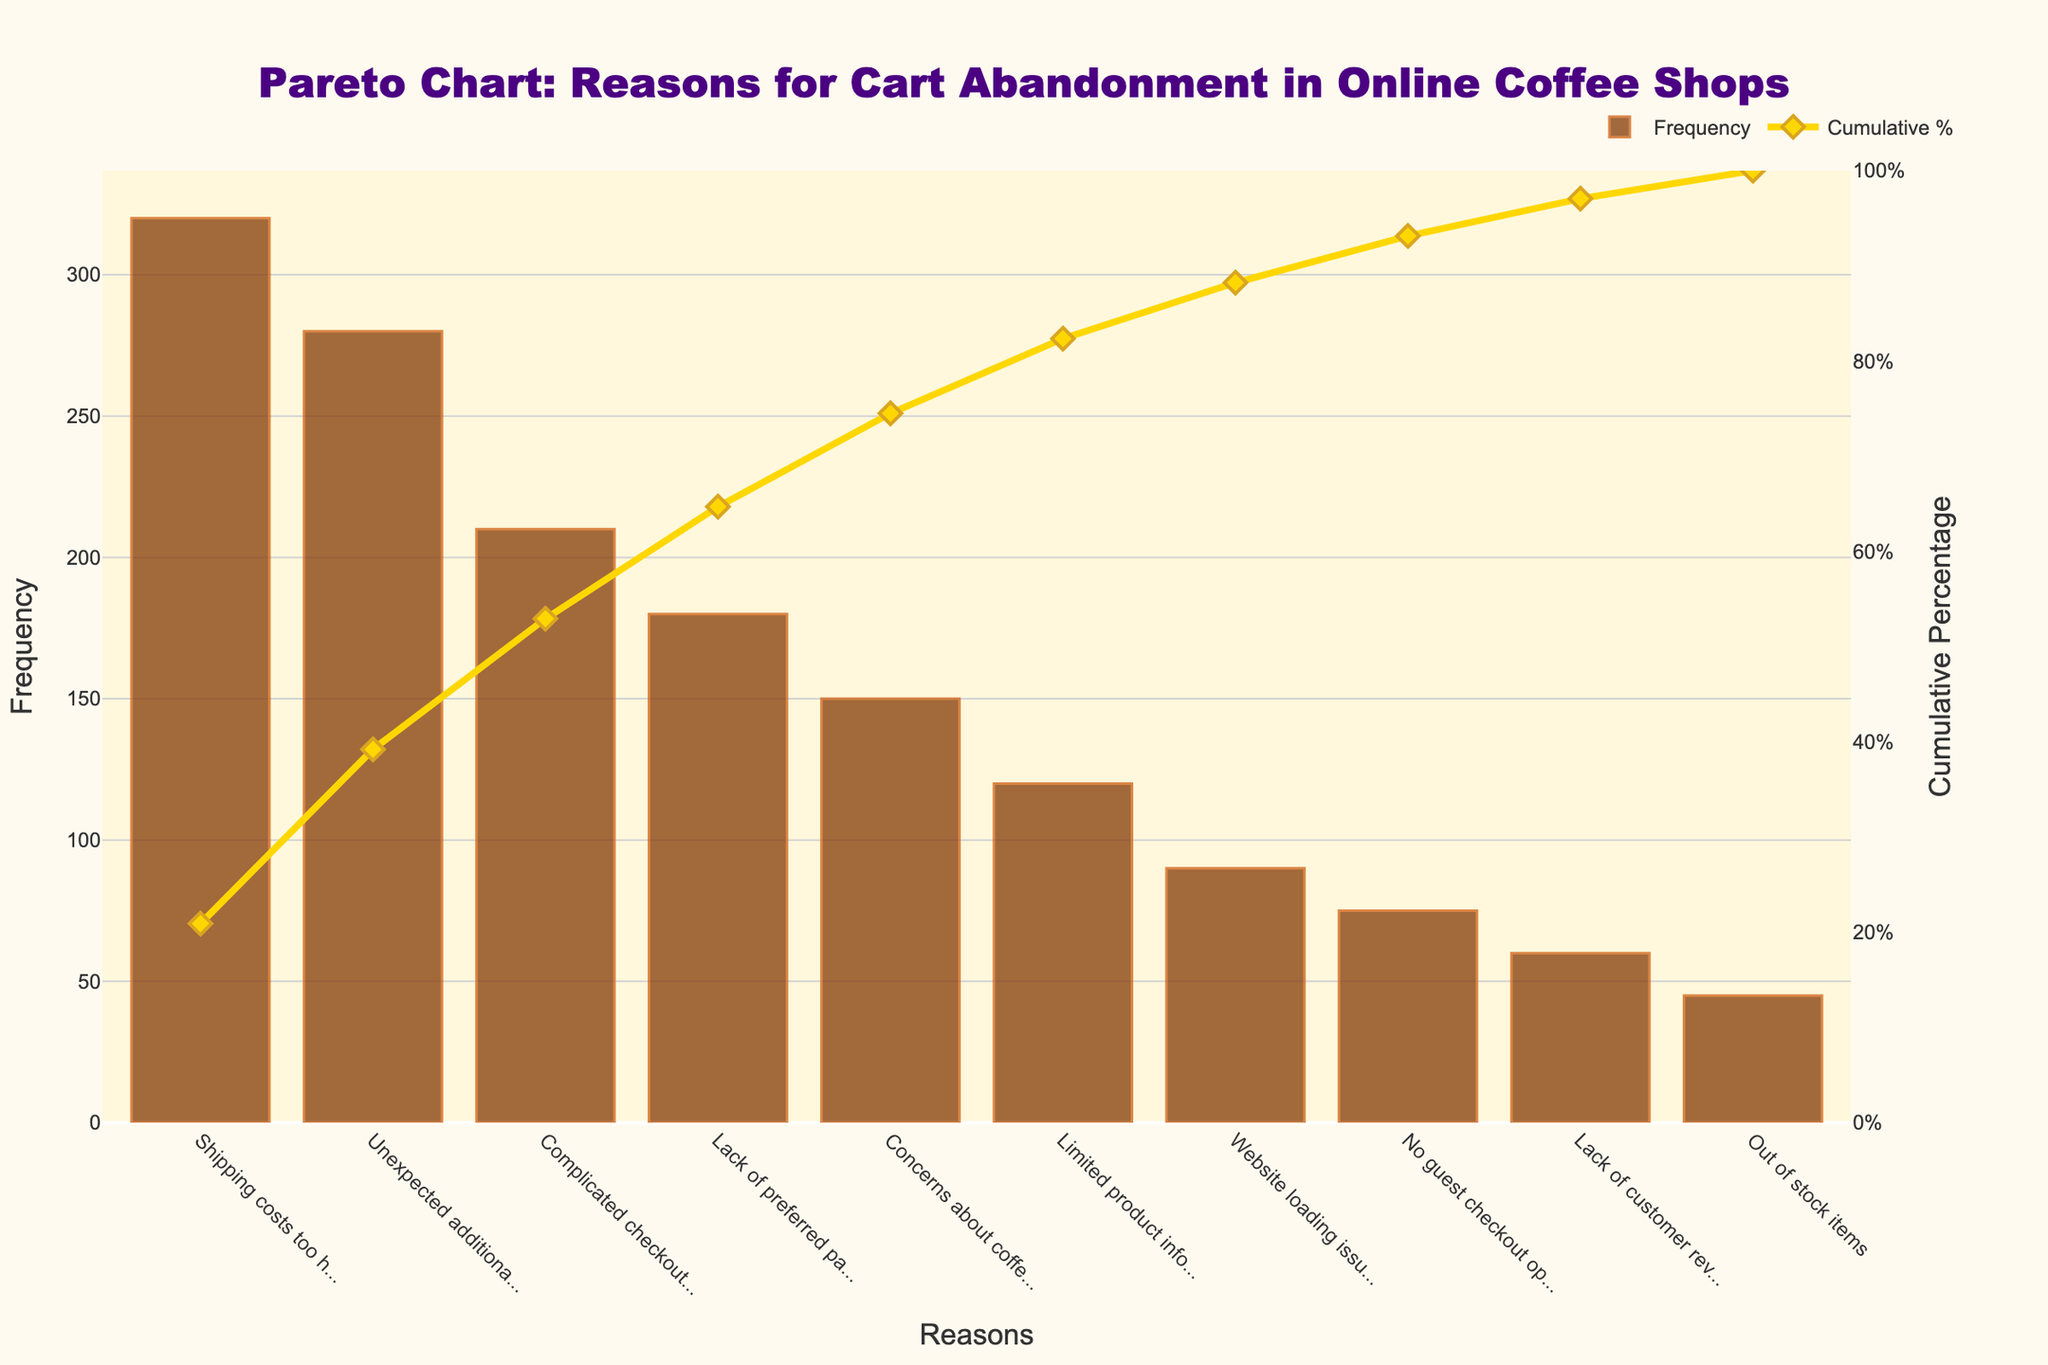What is the most common reason for cart abandonment? The bar with the highest frequency indicates the most common reason. "Shipping costs too high" has the highest frequency at 320.
Answer: Shipping costs too high What percentage of cart abandonment reasons do the top three reasons account for together? The cumulative percentages are shown on the line chart. The top three reasons are "Shipping costs too high" (320), "Unexpected additional fees" (280), and "Complicated checkout process" (210). Their cumulative percentage is the value at the third data point, approximately 66%.
Answer: Approximately 66% How many reasons account for more than 50% of the cart abandonment cases? The cumulative percentage line chart shows the cumulative distribution. Find the number of reasons until the cumulative percentage exceeds 50%. This occurs at the second data point.
Answer: 2 Which reason has the lowest frequency for cart abandonment? The bar with the shortest length indicates the lowest frequency. "Out of stock items" has the lowest frequency at 45.
Answer: Out of stock items What is the cumulative percentage of the top reason for cart abandonment? The cumulative percentage for "Shipping costs too high" can be read directly off the cumulative percentage line chart at its data point, around 26.3%.
Answer: Approximately 26.3% Is "Lack of preferred payment method" a higher cause of abandonment than "Concerns about coffee freshness"? By comparing the bar lengths for each reason, "Lack of preferred payment method" (180) is higher than "Concerns about coffee freshness" (150).
Answer: Yes What is the total frequency of the top five reasons for cart abandonment? Sum the frequencies of the top five reasons: 320 + 280 + 210 + 180 + 150 = 1140.
Answer: 1140 Which reason contributes to nearly reaching the cumulative percentage of 75%? By observing the cumulative percentage line chart, "Lack of preferred payment method" at around 75% is the key contributor.
Answer: Lack of preferred payment method How many reasons have frequencies of 100 or more? Count the bars that have a frequency of 100 or more: there are five such reasons.
Answer: 5 What is the cumulative percentage of cart abandonment reasons by the time we include "Limited product information"? "Limited product information" is the sixth reason on the list. In the cumulative percentage line chart, the value at this point is approximately 89.6%.
Answer: Approximately 89.6% 